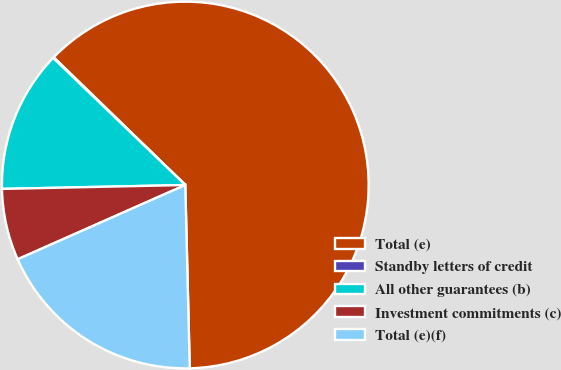<chart> <loc_0><loc_0><loc_500><loc_500><pie_chart><fcel>Total (e)<fcel>Standby letters of credit<fcel>All other guarantees (b)<fcel>Investment commitments (c)<fcel>Total (e)(f)<nl><fcel>62.36%<fcel>0.07%<fcel>12.53%<fcel>6.3%<fcel>18.75%<nl></chart> 